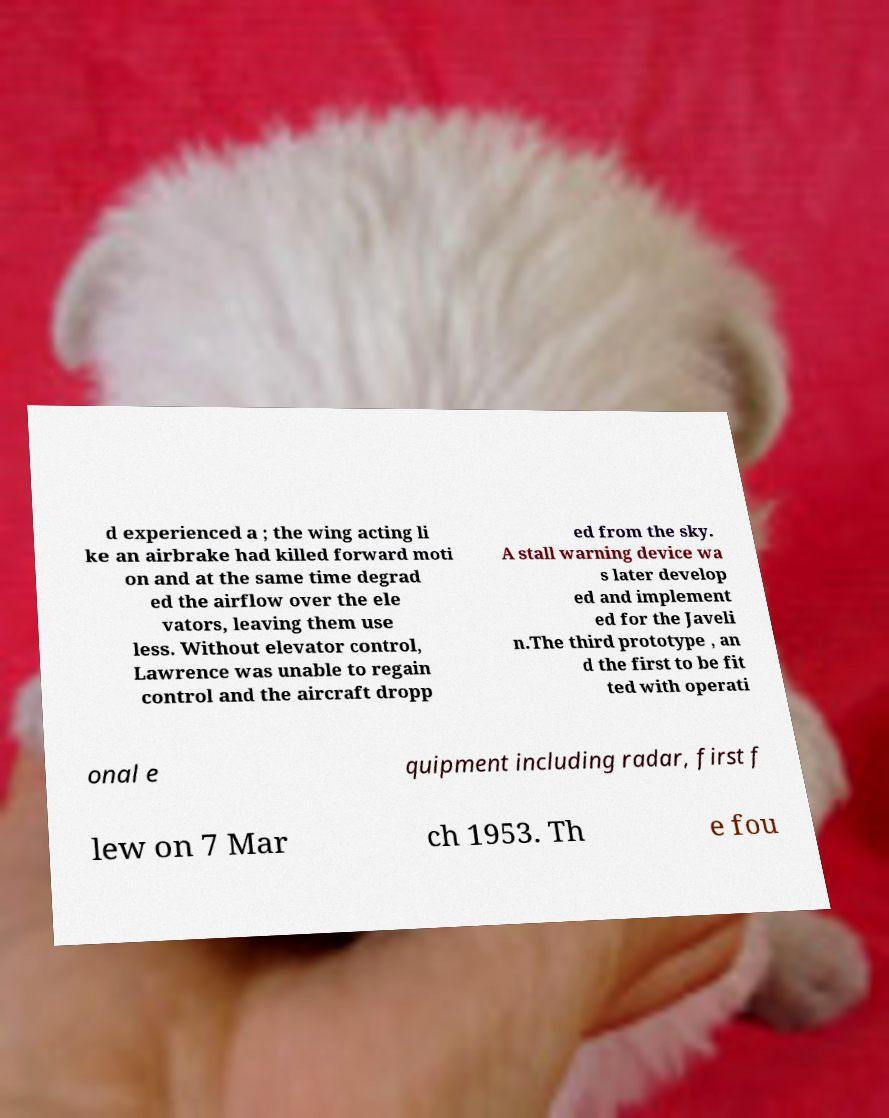Can you read and provide the text displayed in the image?This photo seems to have some interesting text. Can you extract and type it out for me? d experienced a ; the wing acting li ke an airbrake had killed forward moti on and at the same time degrad ed the airflow over the ele vators, leaving them use less. Without elevator control, Lawrence was unable to regain control and the aircraft dropp ed from the sky. A stall warning device wa s later develop ed and implement ed for the Javeli n.The third prototype , an d the first to be fit ted with operati onal e quipment including radar, first f lew on 7 Mar ch 1953. Th e fou 